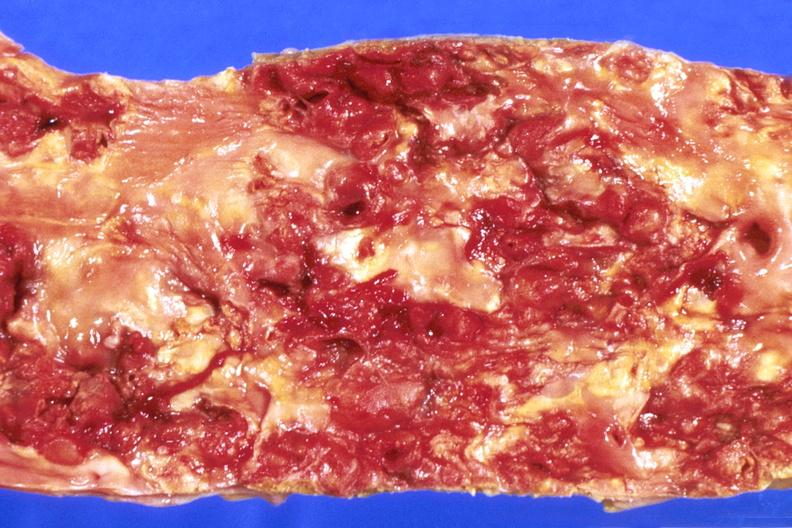what is present?
Answer the question using a single word or phrase. Cardiovascular 